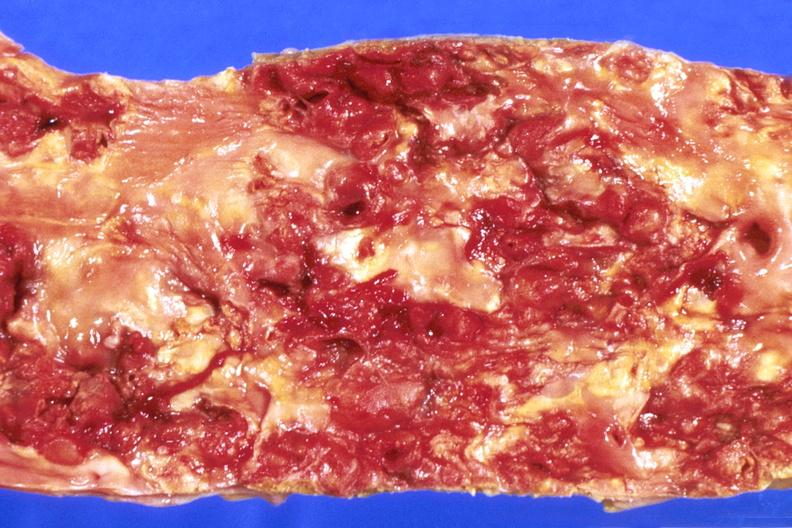what is present?
Answer the question using a single word or phrase. Cardiovascular 